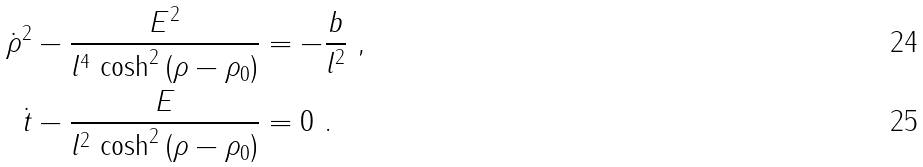Convert formula to latex. <formula><loc_0><loc_0><loc_500><loc_500>\dot { \rho } ^ { 2 } - \frac { E ^ { 2 } } { l ^ { 4 } \, \cosh ^ { 2 } \left ( \rho - \rho _ { 0 } \right ) } & = - \frac { b } { l ^ { 2 } } \ , \\ \dot { t } - \frac { E } { l ^ { 2 } \, \cosh ^ { 2 } \left ( \rho - \rho _ { 0 } \right ) } & = 0 \ .</formula> 